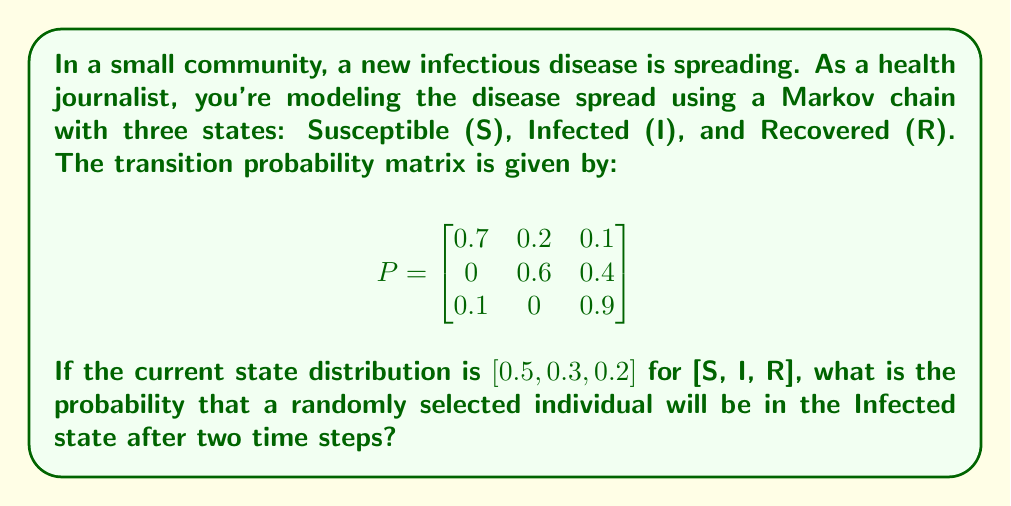Could you help me with this problem? To solve this problem, we need to use the properties of Markov chains and matrix multiplication. Let's approach this step-by-step:

1) Let $\pi_0 = [0.5, 0.3, 0.2]$ be the initial state distribution.

2) To find the state distribution after two time steps, we need to multiply $\pi_0$ by $P$ twice:

   $\pi_2 = \pi_0 P^2$

3) First, let's calculate $P^2$:

   $P^2 = P \times P = \begin{bmatrix}
   0.7 & 0.2 & 0.1 \\
   0 & 0.6 & 0.4 \\
   0.1 & 0 & 0.9
   \end{bmatrix} \times \begin{bmatrix}
   0.7 & 0.2 & 0.1 \\
   0 & 0.6 & 0.4 \\
   0.1 & 0 & 0.9
   \end{bmatrix}$

   $P^2 = \begin{bmatrix}
   0.52 & 0.26 & 0.22 \\
   0.04 & 0.36 & 0.60 \\
   0.16 & 0.18 & 0.66
   \end{bmatrix}$

4) Now, we can calculate $\pi_2$:

   $\pi_2 = [0.5, 0.3, 0.2] \times \begin{bmatrix}
   0.52 & 0.26 & 0.22 \\
   0.04 & 0.36 & 0.60 \\
   0.16 & 0.18 & 0.66
   \end{bmatrix}$

5) Performing the matrix multiplication:

   $\pi_2 = [0.5(0.52) + 0.3(0.04) + 0.2(0.16), 0.5(0.26) + 0.3(0.36) + 0.2(0.18), 0.5(0.22) + 0.3(0.60) + 0.2(0.66)]$

   $\pi_2 = [0.292, 0.268, 0.44]$

6) The probability of being in the Infected state (I) after two time steps is the second element of $\pi_2$, which is 0.268.
Answer: 0.268 